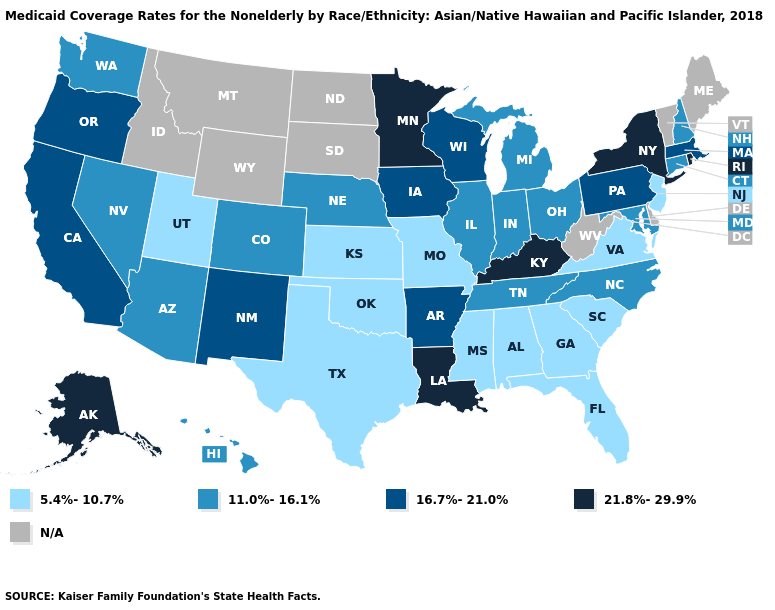What is the value of South Carolina?
Answer briefly. 5.4%-10.7%. Name the states that have a value in the range 11.0%-16.1%?
Concise answer only. Arizona, Colorado, Connecticut, Hawaii, Illinois, Indiana, Maryland, Michigan, Nebraska, Nevada, New Hampshire, North Carolina, Ohio, Tennessee, Washington. Name the states that have a value in the range N/A?
Give a very brief answer. Delaware, Idaho, Maine, Montana, North Dakota, South Dakota, Vermont, West Virginia, Wyoming. What is the lowest value in the Northeast?
Short answer required. 5.4%-10.7%. What is the lowest value in the USA?
Short answer required. 5.4%-10.7%. Name the states that have a value in the range 11.0%-16.1%?
Concise answer only. Arizona, Colorado, Connecticut, Hawaii, Illinois, Indiana, Maryland, Michigan, Nebraska, Nevada, New Hampshire, North Carolina, Ohio, Tennessee, Washington. Name the states that have a value in the range 5.4%-10.7%?
Keep it brief. Alabama, Florida, Georgia, Kansas, Mississippi, Missouri, New Jersey, Oklahoma, South Carolina, Texas, Utah, Virginia. Name the states that have a value in the range 21.8%-29.9%?
Quick response, please. Alaska, Kentucky, Louisiana, Minnesota, New York, Rhode Island. What is the lowest value in the USA?
Answer briefly. 5.4%-10.7%. Which states have the lowest value in the USA?
Be succinct. Alabama, Florida, Georgia, Kansas, Mississippi, Missouri, New Jersey, Oklahoma, South Carolina, Texas, Utah, Virginia. What is the lowest value in the MidWest?
Keep it brief. 5.4%-10.7%. What is the value of Pennsylvania?
Keep it brief. 16.7%-21.0%. Among the states that border Maine , which have the lowest value?
Answer briefly. New Hampshire. Does Missouri have the lowest value in the MidWest?
Quick response, please. Yes. 